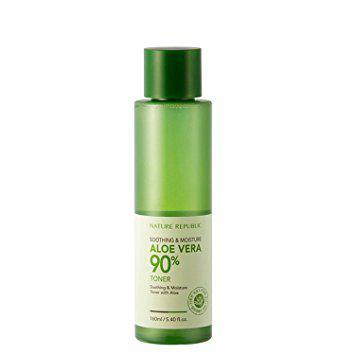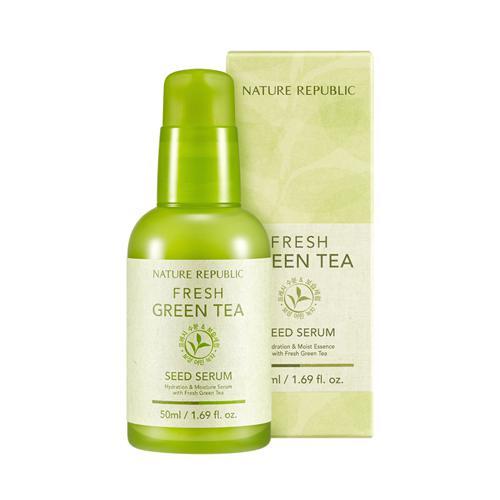The first image is the image on the left, the second image is the image on the right. Examine the images to the left and right. Is the description "An image includes just one product next to a box: a green bottle without a white label." accurate? Answer yes or no. No. The first image is the image on the left, the second image is the image on the right. Given the left and right images, does the statement "There are two products in total in the pair of images." hold true? Answer yes or no. Yes. 